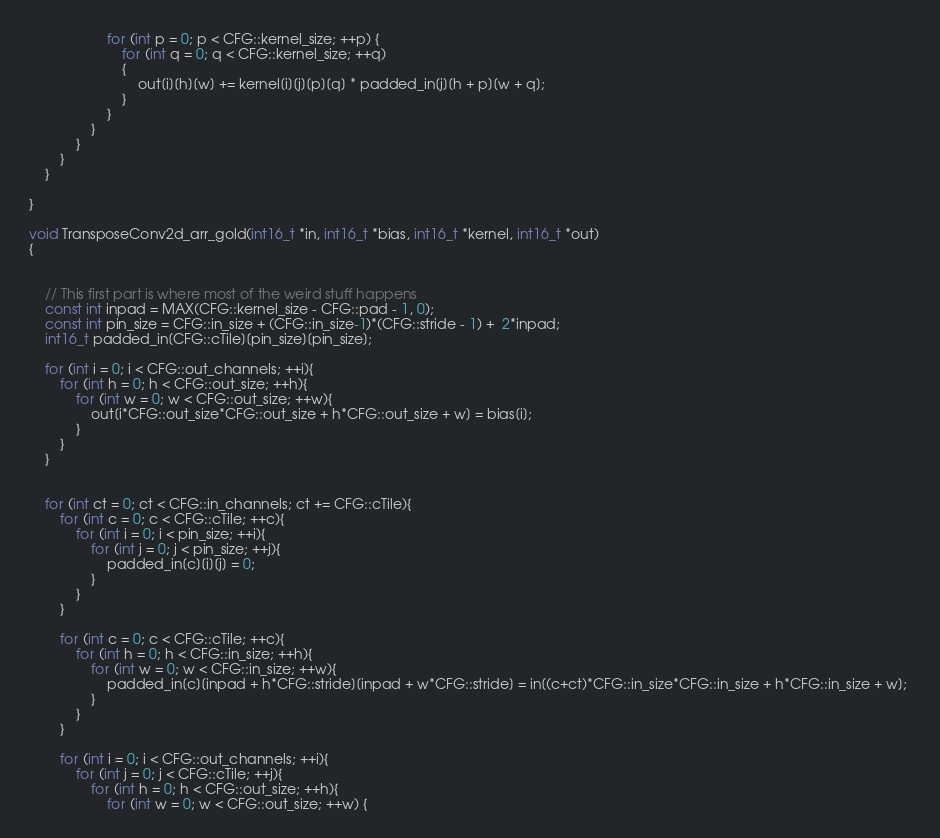Convert code to text. <code><loc_0><loc_0><loc_500><loc_500><_C++_>                    for (int p = 0; p < CFG::kernel_size; ++p) {
                        for (int q = 0; q < CFG::kernel_size; ++q)
                        {
                            out[i][h][w] += kernel[i][j][p][q] * padded_in[j][h + p][w + q];
                        }
                    }
                }
            }
        }
    }
    
}

void TransposeConv2d_arr_gold(int16_t *in, int16_t *bias, int16_t *kernel, int16_t *out)
{


    // This first part is where most of the weird stuff happens
    const int inpad = MAX(CFG::kernel_size - CFG::pad - 1, 0);                           
    const int pin_size = CFG::in_size + (CFG::in_size-1)*(CFG::stride - 1) +  2*inpad;
    int16_t padded_in[CFG::cTile][pin_size][pin_size];

    for (int i = 0; i < CFG::out_channels; ++i){
        for (int h = 0; h < CFG::out_size; ++h){
            for (int w = 0; w < CFG::out_size; ++w){
                out[i*CFG::out_size*CFG::out_size + h*CFG::out_size + w] = bias[i];
            }
        }
    }
    
    
    for (int ct = 0; ct < CFG::in_channels; ct += CFG::cTile){
        for (int c = 0; c < CFG::cTile; ++c){
            for (int i = 0; i < pin_size; ++i){
                for (int j = 0; j < pin_size; ++j){
                    padded_in[c][i][j] = 0;
                }
            }
        }

        for (int c = 0; c < CFG::cTile; ++c){
            for (int h = 0; h < CFG::in_size; ++h){
                for (int w = 0; w < CFG::in_size; ++w){
                    padded_in[c][inpad + h*CFG::stride][inpad + w*CFG::stride] = in[(c+ct)*CFG::in_size*CFG::in_size + h*CFG::in_size + w]; 
                }
            }
        }

        for (int i = 0; i < CFG::out_channels; ++i){
            for (int j = 0; j < CFG::cTile; ++j){
                for (int h = 0; h < CFG::out_size; ++h){
                    for (int w = 0; w < CFG::out_size; ++w) {</code> 